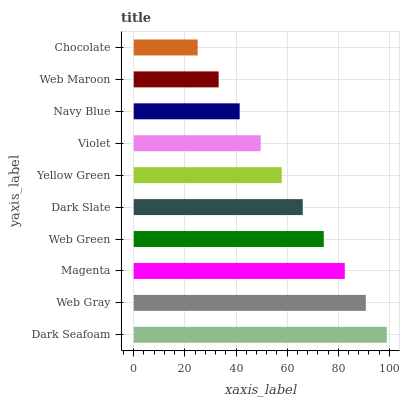Is Chocolate the minimum?
Answer yes or no. Yes. Is Dark Seafoam the maximum?
Answer yes or no. Yes. Is Web Gray the minimum?
Answer yes or no. No. Is Web Gray the maximum?
Answer yes or no. No. Is Dark Seafoam greater than Web Gray?
Answer yes or no. Yes. Is Web Gray less than Dark Seafoam?
Answer yes or no. Yes. Is Web Gray greater than Dark Seafoam?
Answer yes or no. No. Is Dark Seafoam less than Web Gray?
Answer yes or no. No. Is Dark Slate the high median?
Answer yes or no. Yes. Is Yellow Green the low median?
Answer yes or no. Yes. Is Yellow Green the high median?
Answer yes or no. No. Is Violet the low median?
Answer yes or no. No. 